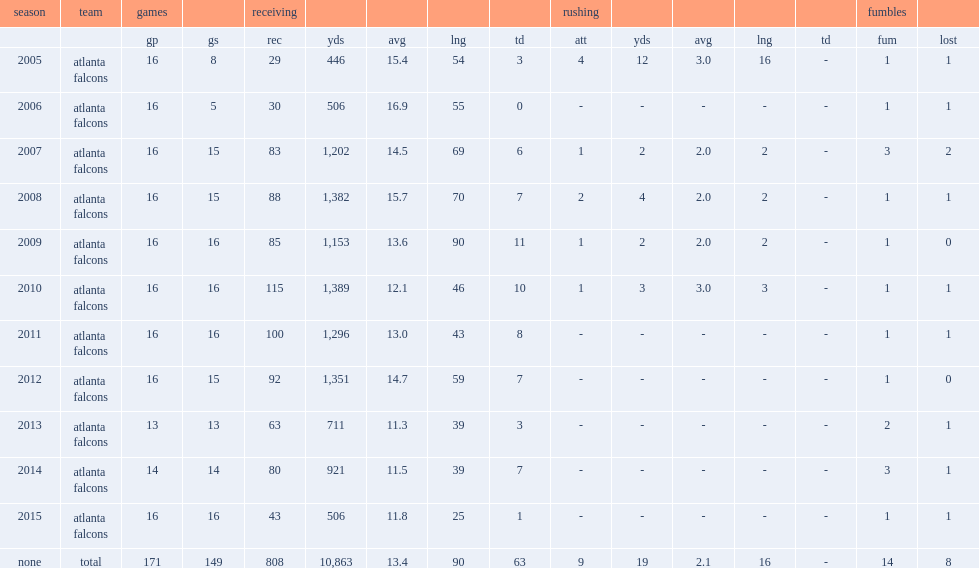How many receptions did roddy white get in 2011. 100.0. 